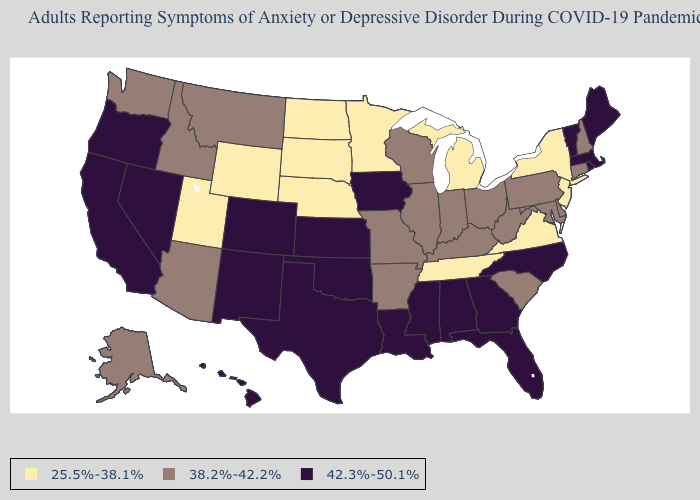Does Texas have the lowest value in the South?
Give a very brief answer. No. What is the value of Colorado?
Write a very short answer. 42.3%-50.1%. What is the value of Maryland?
Write a very short answer. 38.2%-42.2%. Name the states that have a value in the range 38.2%-42.2%?
Keep it brief. Alaska, Arizona, Arkansas, Connecticut, Delaware, Idaho, Illinois, Indiana, Kentucky, Maryland, Missouri, Montana, New Hampshire, Ohio, Pennsylvania, South Carolina, Washington, West Virginia, Wisconsin. Does the first symbol in the legend represent the smallest category?
Keep it brief. Yes. What is the value of Alabama?
Concise answer only. 42.3%-50.1%. Name the states that have a value in the range 38.2%-42.2%?
Answer briefly. Alaska, Arizona, Arkansas, Connecticut, Delaware, Idaho, Illinois, Indiana, Kentucky, Maryland, Missouri, Montana, New Hampshire, Ohio, Pennsylvania, South Carolina, Washington, West Virginia, Wisconsin. Name the states that have a value in the range 25.5%-38.1%?
Answer briefly. Michigan, Minnesota, Nebraska, New Jersey, New York, North Dakota, South Dakota, Tennessee, Utah, Virginia, Wyoming. Does Rhode Island have the highest value in the Northeast?
Give a very brief answer. Yes. What is the lowest value in the USA?
Keep it brief. 25.5%-38.1%. What is the value of Arizona?
Be succinct. 38.2%-42.2%. Does Hawaii have the highest value in the West?
Keep it brief. Yes. Name the states that have a value in the range 25.5%-38.1%?
Keep it brief. Michigan, Minnesota, Nebraska, New Jersey, New York, North Dakota, South Dakota, Tennessee, Utah, Virginia, Wyoming. 